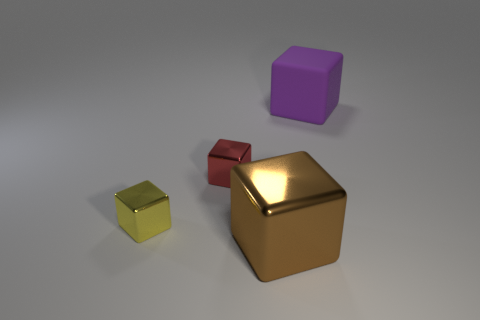Subtract all big purple rubber cubes. How many cubes are left? 3 Subtract 2 blocks. How many blocks are left? 2 Subtract all yellow cubes. How many cubes are left? 3 Add 1 tiny yellow shiny cubes. How many tiny yellow shiny cubes are left? 2 Add 4 shiny cylinders. How many shiny cylinders exist? 4 Add 3 large blue rubber cylinders. How many objects exist? 7 Subtract 0 purple cylinders. How many objects are left? 4 Subtract all brown blocks. Subtract all cyan spheres. How many blocks are left? 3 Subtract all purple spheres. How many brown cubes are left? 1 Subtract all big metallic objects. Subtract all large brown shiny blocks. How many objects are left? 2 